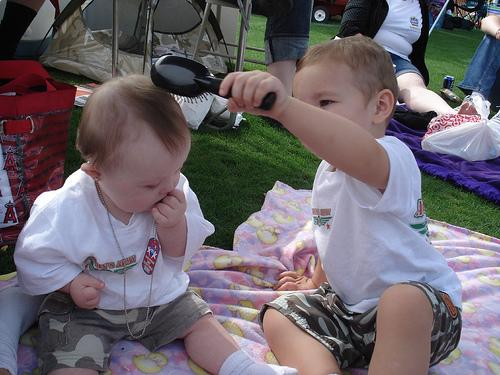What syndrome does the baby on the left have? down syndrome 